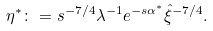<formula> <loc_0><loc_0><loc_500><loc_500>\eta ^ { * } \colon = s ^ { - 7 / 4 } \lambda ^ { - 1 } e ^ { - s \alpha ^ { * } } \hat { \xi } ^ { - 7 / 4 } .</formula> 